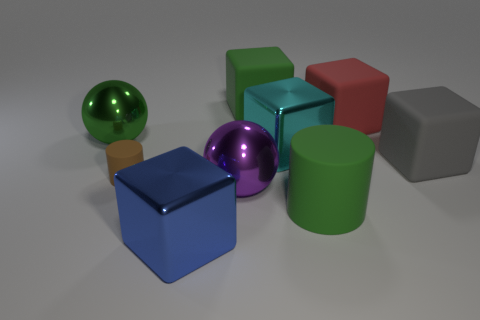Do the green cube and the gray block have the same size?
Provide a succinct answer. Yes. What number of things are either red matte balls or big blue metallic cubes that are on the left side of the big green rubber block?
Your response must be concise. 1. What color is the cylinder that is left of the large cube behind the big red cube?
Provide a succinct answer. Brown. Do the big rubber object on the left side of the cyan cube and the large rubber cylinder have the same color?
Keep it short and to the point. Yes. There is a green object in front of the purple thing; what material is it?
Your answer should be very brief. Rubber. How big is the purple object?
Give a very brief answer. Large. Is the material of the green object that is in front of the purple ball the same as the red cube?
Ensure brevity in your answer.  Yes. What number of large shiny cubes are there?
Give a very brief answer. 2. How many objects are either large metal cubes or large green blocks?
Keep it short and to the point. 3. There is a metal cube that is in front of the rubber block that is in front of the large green metal ball; what number of green things are behind it?
Offer a very short reply. 3. 